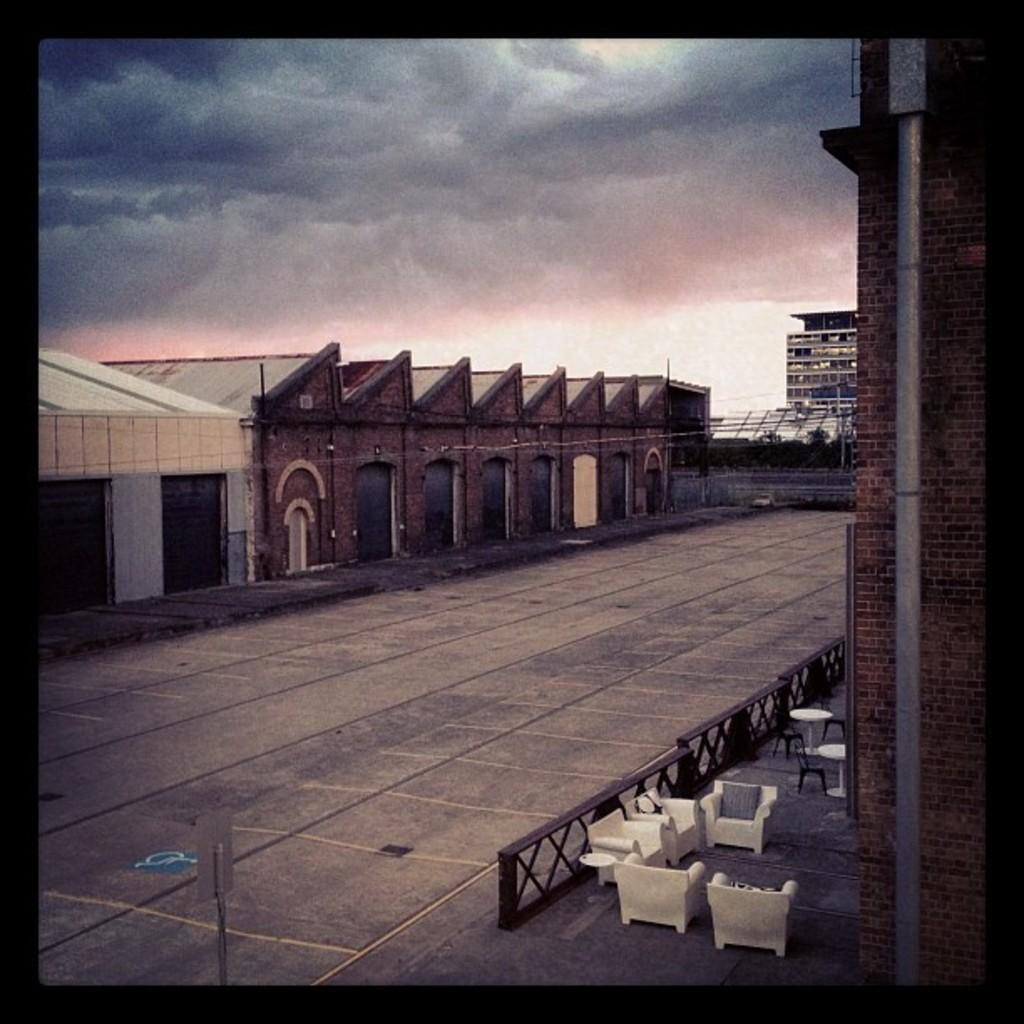What type of furniture is present in the image? There are chairs and tables in the image. Where are the chairs and tables located? The chairs and tables are on the ground. What can be seen in the background of the image? There are buildings and the sky visible in the background of the image. Can you describe the unspecified objects in the background of the image? There are some unspecified objects in the background of the image. What type of frame is holding the parcel in the image? There is no parcel or frame present in the image. 